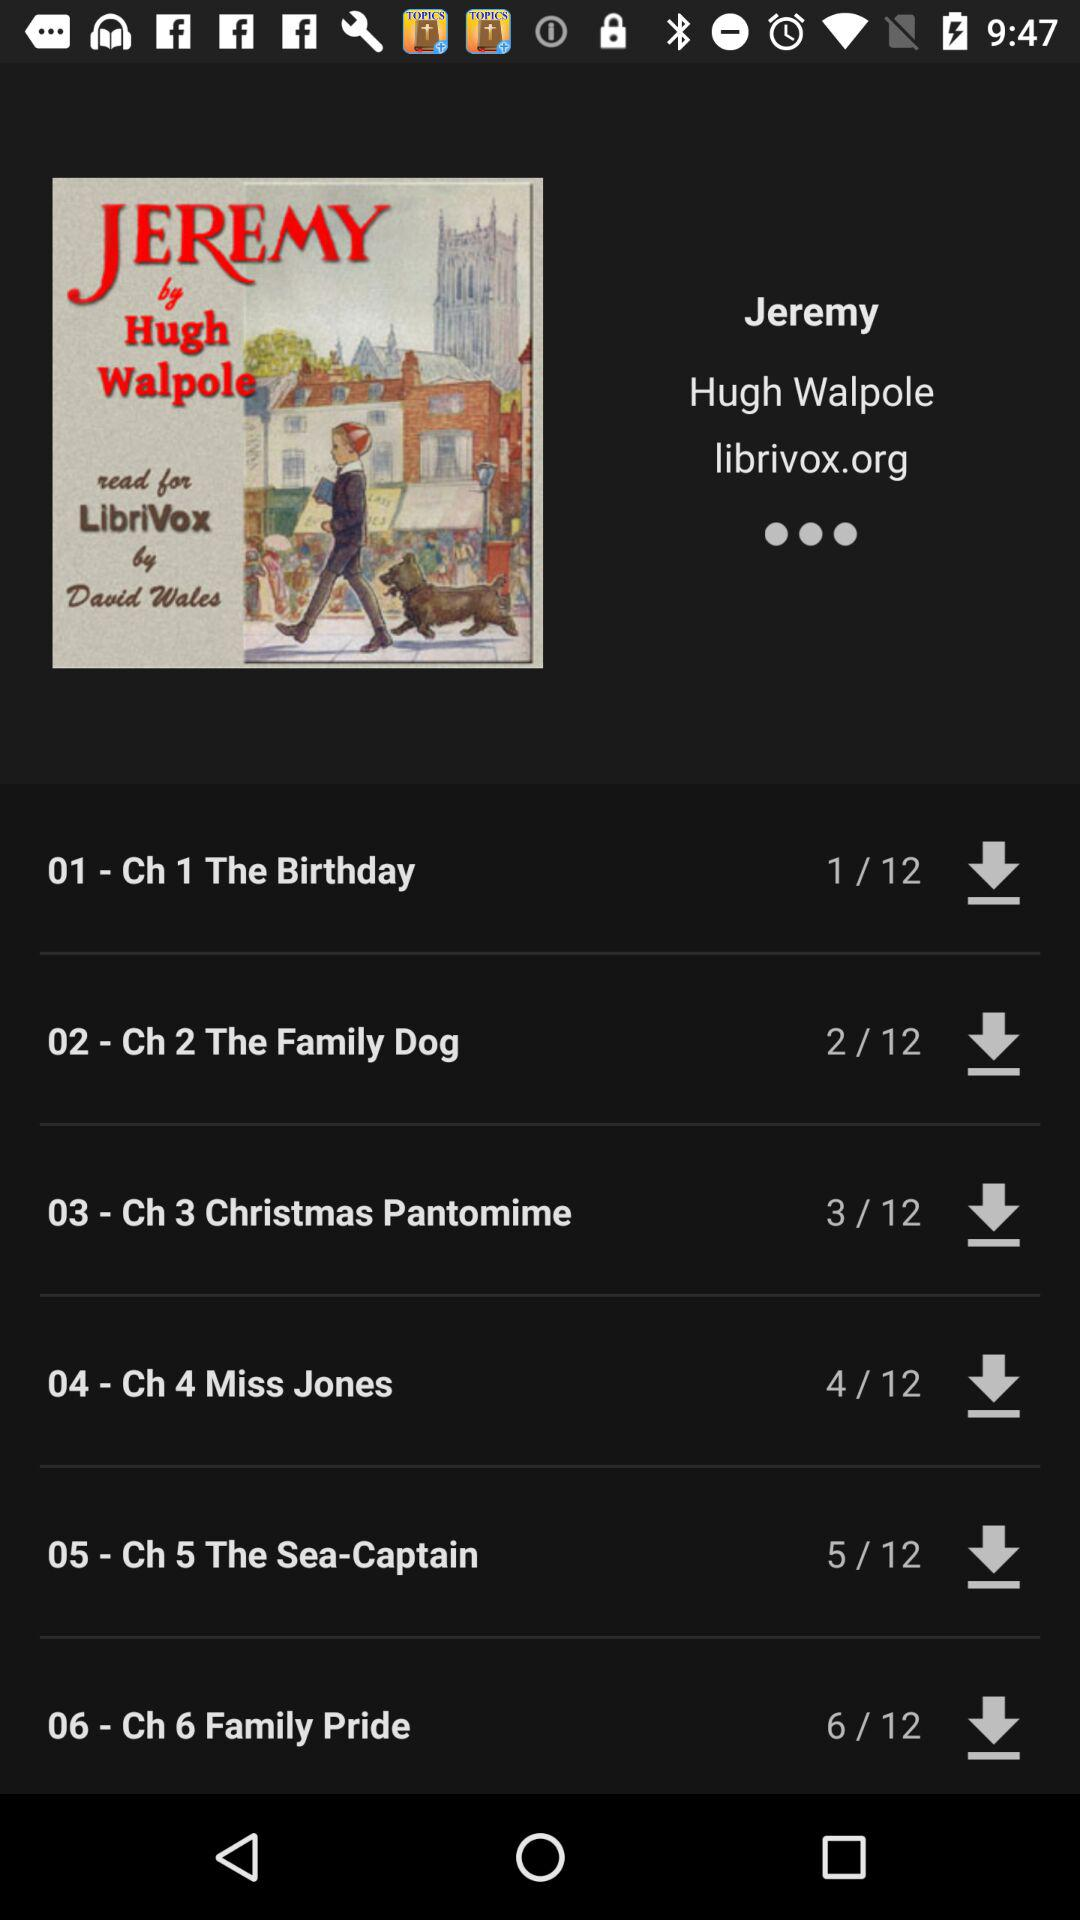How many downloads of chapter 4? There are 4 downloads. 